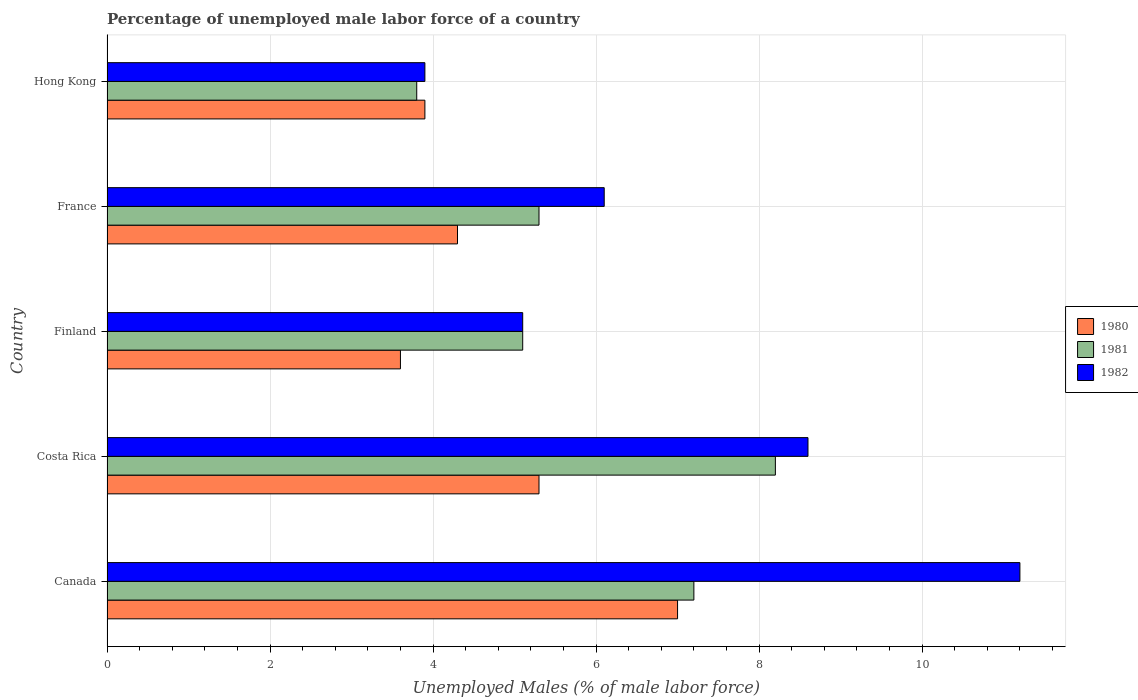How many groups of bars are there?
Your answer should be compact. 5. Are the number of bars per tick equal to the number of legend labels?
Your answer should be compact. Yes. In how many cases, is the number of bars for a given country not equal to the number of legend labels?
Your response must be concise. 0. What is the percentage of unemployed male labor force in 1981 in Finland?
Offer a very short reply. 5.1. Across all countries, what is the maximum percentage of unemployed male labor force in 1982?
Your answer should be very brief. 11.2. Across all countries, what is the minimum percentage of unemployed male labor force in 1981?
Your answer should be compact. 3.8. In which country was the percentage of unemployed male labor force in 1980 minimum?
Your answer should be very brief. Finland. What is the total percentage of unemployed male labor force in 1981 in the graph?
Offer a terse response. 29.6. What is the difference between the percentage of unemployed male labor force in 1982 in Canada and that in France?
Offer a terse response. 5.1. What is the difference between the percentage of unemployed male labor force in 1982 in Hong Kong and the percentage of unemployed male labor force in 1981 in France?
Ensure brevity in your answer.  -1.4. What is the average percentage of unemployed male labor force in 1982 per country?
Your answer should be compact. 6.98. What is the difference between the percentage of unemployed male labor force in 1981 and percentage of unemployed male labor force in 1980 in Costa Rica?
Give a very brief answer. 2.9. What is the ratio of the percentage of unemployed male labor force in 1981 in Finland to that in Hong Kong?
Offer a terse response. 1.34. Is the difference between the percentage of unemployed male labor force in 1981 in France and Hong Kong greater than the difference between the percentage of unemployed male labor force in 1980 in France and Hong Kong?
Your response must be concise. Yes. What is the difference between the highest and the second highest percentage of unemployed male labor force in 1980?
Your answer should be very brief. 1.7. What is the difference between the highest and the lowest percentage of unemployed male labor force in 1982?
Ensure brevity in your answer.  7.3. Is the sum of the percentage of unemployed male labor force in 1981 in Costa Rica and Finland greater than the maximum percentage of unemployed male labor force in 1980 across all countries?
Keep it short and to the point. Yes. What does the 3rd bar from the top in France represents?
Make the answer very short. 1980. Is it the case that in every country, the sum of the percentage of unemployed male labor force in 1981 and percentage of unemployed male labor force in 1980 is greater than the percentage of unemployed male labor force in 1982?
Ensure brevity in your answer.  Yes. What is the difference between two consecutive major ticks on the X-axis?
Your answer should be compact. 2. Does the graph contain any zero values?
Provide a succinct answer. No. Does the graph contain grids?
Your response must be concise. Yes. What is the title of the graph?
Offer a terse response. Percentage of unemployed male labor force of a country. Does "1993" appear as one of the legend labels in the graph?
Keep it short and to the point. No. What is the label or title of the X-axis?
Provide a short and direct response. Unemployed Males (% of male labor force). What is the label or title of the Y-axis?
Keep it short and to the point. Country. What is the Unemployed Males (% of male labor force) of 1981 in Canada?
Ensure brevity in your answer.  7.2. What is the Unemployed Males (% of male labor force) in 1982 in Canada?
Make the answer very short. 11.2. What is the Unemployed Males (% of male labor force) in 1980 in Costa Rica?
Offer a terse response. 5.3. What is the Unemployed Males (% of male labor force) in 1981 in Costa Rica?
Provide a short and direct response. 8.2. What is the Unemployed Males (% of male labor force) of 1982 in Costa Rica?
Provide a succinct answer. 8.6. What is the Unemployed Males (% of male labor force) of 1980 in Finland?
Ensure brevity in your answer.  3.6. What is the Unemployed Males (% of male labor force) of 1981 in Finland?
Ensure brevity in your answer.  5.1. What is the Unemployed Males (% of male labor force) of 1982 in Finland?
Ensure brevity in your answer.  5.1. What is the Unemployed Males (% of male labor force) in 1980 in France?
Make the answer very short. 4.3. What is the Unemployed Males (% of male labor force) of 1981 in France?
Give a very brief answer. 5.3. What is the Unemployed Males (% of male labor force) in 1982 in France?
Your answer should be compact. 6.1. What is the Unemployed Males (% of male labor force) of 1980 in Hong Kong?
Provide a succinct answer. 3.9. What is the Unemployed Males (% of male labor force) of 1981 in Hong Kong?
Provide a succinct answer. 3.8. What is the Unemployed Males (% of male labor force) in 1982 in Hong Kong?
Provide a succinct answer. 3.9. Across all countries, what is the maximum Unemployed Males (% of male labor force) in 1980?
Your answer should be compact. 7. Across all countries, what is the maximum Unemployed Males (% of male labor force) of 1981?
Offer a terse response. 8.2. Across all countries, what is the maximum Unemployed Males (% of male labor force) in 1982?
Ensure brevity in your answer.  11.2. Across all countries, what is the minimum Unemployed Males (% of male labor force) in 1980?
Your response must be concise. 3.6. Across all countries, what is the minimum Unemployed Males (% of male labor force) in 1981?
Offer a very short reply. 3.8. Across all countries, what is the minimum Unemployed Males (% of male labor force) in 1982?
Your answer should be very brief. 3.9. What is the total Unemployed Males (% of male labor force) of 1980 in the graph?
Offer a very short reply. 24.1. What is the total Unemployed Males (% of male labor force) of 1981 in the graph?
Provide a succinct answer. 29.6. What is the total Unemployed Males (% of male labor force) in 1982 in the graph?
Your response must be concise. 34.9. What is the difference between the Unemployed Males (% of male labor force) of 1980 in Canada and that in Costa Rica?
Offer a terse response. 1.7. What is the difference between the Unemployed Males (% of male labor force) of 1981 in Canada and that in Costa Rica?
Your response must be concise. -1. What is the difference between the Unemployed Males (% of male labor force) in 1982 in Canada and that in Costa Rica?
Keep it short and to the point. 2.6. What is the difference between the Unemployed Males (% of male labor force) of 1980 in Canada and that in Finland?
Ensure brevity in your answer.  3.4. What is the difference between the Unemployed Males (% of male labor force) of 1981 in Canada and that in Finland?
Ensure brevity in your answer.  2.1. What is the difference between the Unemployed Males (% of male labor force) in 1982 in Canada and that in France?
Provide a short and direct response. 5.1. What is the difference between the Unemployed Males (% of male labor force) of 1980 in Canada and that in Hong Kong?
Ensure brevity in your answer.  3.1. What is the difference between the Unemployed Males (% of male labor force) of 1980 in Costa Rica and that in Finland?
Provide a short and direct response. 1.7. What is the difference between the Unemployed Males (% of male labor force) in 1982 in Costa Rica and that in France?
Make the answer very short. 2.5. What is the difference between the Unemployed Males (% of male labor force) of 1980 in Costa Rica and that in Hong Kong?
Ensure brevity in your answer.  1.4. What is the difference between the Unemployed Males (% of male labor force) in 1982 in Costa Rica and that in Hong Kong?
Keep it short and to the point. 4.7. What is the difference between the Unemployed Males (% of male labor force) of 1980 in Finland and that in Hong Kong?
Your answer should be very brief. -0.3. What is the difference between the Unemployed Males (% of male labor force) of 1981 in France and that in Hong Kong?
Make the answer very short. 1.5. What is the difference between the Unemployed Males (% of male labor force) in 1980 in Canada and the Unemployed Males (% of male labor force) in 1982 in Costa Rica?
Offer a very short reply. -1.6. What is the difference between the Unemployed Males (% of male labor force) in 1981 in Canada and the Unemployed Males (% of male labor force) in 1982 in Costa Rica?
Keep it short and to the point. -1.4. What is the difference between the Unemployed Males (% of male labor force) in 1980 in Canada and the Unemployed Males (% of male labor force) in 1981 in Finland?
Keep it short and to the point. 1.9. What is the difference between the Unemployed Males (% of male labor force) of 1981 in Canada and the Unemployed Males (% of male labor force) of 1982 in Finland?
Ensure brevity in your answer.  2.1. What is the difference between the Unemployed Males (% of male labor force) of 1980 in Canada and the Unemployed Males (% of male labor force) of 1982 in France?
Your answer should be very brief. 0.9. What is the difference between the Unemployed Males (% of male labor force) in 1981 in Canada and the Unemployed Males (% of male labor force) in 1982 in France?
Give a very brief answer. 1.1. What is the difference between the Unemployed Males (% of male labor force) in 1980 in Canada and the Unemployed Males (% of male labor force) in 1981 in Hong Kong?
Provide a succinct answer. 3.2. What is the difference between the Unemployed Males (% of male labor force) of 1980 in Canada and the Unemployed Males (% of male labor force) of 1982 in Hong Kong?
Ensure brevity in your answer.  3.1. What is the difference between the Unemployed Males (% of male labor force) of 1980 in Costa Rica and the Unemployed Males (% of male labor force) of 1982 in France?
Give a very brief answer. -0.8. What is the difference between the Unemployed Males (% of male labor force) of 1981 in Costa Rica and the Unemployed Males (% of male labor force) of 1982 in France?
Provide a succinct answer. 2.1. What is the difference between the Unemployed Males (% of male labor force) of 1981 in Costa Rica and the Unemployed Males (% of male labor force) of 1982 in Hong Kong?
Give a very brief answer. 4.3. What is the difference between the Unemployed Males (% of male labor force) of 1980 in Finland and the Unemployed Males (% of male labor force) of 1982 in France?
Provide a short and direct response. -2.5. What is the difference between the Unemployed Males (% of male labor force) in 1980 in Finland and the Unemployed Males (% of male labor force) in 1981 in Hong Kong?
Ensure brevity in your answer.  -0.2. What is the difference between the Unemployed Males (% of male labor force) of 1980 in France and the Unemployed Males (% of male labor force) of 1982 in Hong Kong?
Provide a short and direct response. 0.4. What is the average Unemployed Males (% of male labor force) in 1980 per country?
Ensure brevity in your answer.  4.82. What is the average Unemployed Males (% of male labor force) of 1981 per country?
Ensure brevity in your answer.  5.92. What is the average Unemployed Males (% of male labor force) in 1982 per country?
Your answer should be very brief. 6.98. What is the difference between the Unemployed Males (% of male labor force) in 1980 and Unemployed Males (% of male labor force) in 1981 in Canada?
Ensure brevity in your answer.  -0.2. What is the difference between the Unemployed Males (% of male labor force) of 1981 and Unemployed Males (% of male labor force) of 1982 in Canada?
Keep it short and to the point. -4. What is the difference between the Unemployed Males (% of male labor force) in 1980 and Unemployed Males (% of male labor force) in 1981 in Finland?
Make the answer very short. -1.5. What is the difference between the Unemployed Males (% of male labor force) of 1980 and Unemployed Males (% of male labor force) of 1982 in Finland?
Provide a short and direct response. -1.5. What is the difference between the Unemployed Males (% of male labor force) of 1981 and Unemployed Males (% of male labor force) of 1982 in Finland?
Offer a very short reply. 0. What is the difference between the Unemployed Males (% of male labor force) in 1981 and Unemployed Males (% of male labor force) in 1982 in France?
Provide a succinct answer. -0.8. What is the ratio of the Unemployed Males (% of male labor force) in 1980 in Canada to that in Costa Rica?
Your response must be concise. 1.32. What is the ratio of the Unemployed Males (% of male labor force) of 1981 in Canada to that in Costa Rica?
Your response must be concise. 0.88. What is the ratio of the Unemployed Males (% of male labor force) of 1982 in Canada to that in Costa Rica?
Offer a very short reply. 1.3. What is the ratio of the Unemployed Males (% of male labor force) of 1980 in Canada to that in Finland?
Your answer should be very brief. 1.94. What is the ratio of the Unemployed Males (% of male labor force) in 1981 in Canada to that in Finland?
Ensure brevity in your answer.  1.41. What is the ratio of the Unemployed Males (% of male labor force) of 1982 in Canada to that in Finland?
Provide a short and direct response. 2.2. What is the ratio of the Unemployed Males (% of male labor force) of 1980 in Canada to that in France?
Your answer should be compact. 1.63. What is the ratio of the Unemployed Males (% of male labor force) in 1981 in Canada to that in France?
Offer a terse response. 1.36. What is the ratio of the Unemployed Males (% of male labor force) of 1982 in Canada to that in France?
Keep it short and to the point. 1.84. What is the ratio of the Unemployed Males (% of male labor force) of 1980 in Canada to that in Hong Kong?
Ensure brevity in your answer.  1.79. What is the ratio of the Unemployed Males (% of male labor force) in 1981 in Canada to that in Hong Kong?
Give a very brief answer. 1.89. What is the ratio of the Unemployed Males (% of male labor force) of 1982 in Canada to that in Hong Kong?
Ensure brevity in your answer.  2.87. What is the ratio of the Unemployed Males (% of male labor force) in 1980 in Costa Rica to that in Finland?
Offer a very short reply. 1.47. What is the ratio of the Unemployed Males (% of male labor force) of 1981 in Costa Rica to that in Finland?
Keep it short and to the point. 1.61. What is the ratio of the Unemployed Males (% of male labor force) in 1982 in Costa Rica to that in Finland?
Offer a very short reply. 1.69. What is the ratio of the Unemployed Males (% of male labor force) in 1980 in Costa Rica to that in France?
Offer a very short reply. 1.23. What is the ratio of the Unemployed Males (% of male labor force) in 1981 in Costa Rica to that in France?
Offer a very short reply. 1.55. What is the ratio of the Unemployed Males (% of male labor force) in 1982 in Costa Rica to that in France?
Make the answer very short. 1.41. What is the ratio of the Unemployed Males (% of male labor force) of 1980 in Costa Rica to that in Hong Kong?
Offer a very short reply. 1.36. What is the ratio of the Unemployed Males (% of male labor force) in 1981 in Costa Rica to that in Hong Kong?
Provide a succinct answer. 2.16. What is the ratio of the Unemployed Males (% of male labor force) in 1982 in Costa Rica to that in Hong Kong?
Your answer should be very brief. 2.21. What is the ratio of the Unemployed Males (% of male labor force) of 1980 in Finland to that in France?
Your response must be concise. 0.84. What is the ratio of the Unemployed Males (% of male labor force) of 1981 in Finland to that in France?
Your answer should be compact. 0.96. What is the ratio of the Unemployed Males (% of male labor force) of 1982 in Finland to that in France?
Offer a terse response. 0.84. What is the ratio of the Unemployed Males (% of male labor force) of 1981 in Finland to that in Hong Kong?
Ensure brevity in your answer.  1.34. What is the ratio of the Unemployed Males (% of male labor force) in 1982 in Finland to that in Hong Kong?
Offer a very short reply. 1.31. What is the ratio of the Unemployed Males (% of male labor force) in 1980 in France to that in Hong Kong?
Keep it short and to the point. 1.1. What is the ratio of the Unemployed Males (% of male labor force) of 1981 in France to that in Hong Kong?
Your answer should be compact. 1.39. What is the ratio of the Unemployed Males (% of male labor force) of 1982 in France to that in Hong Kong?
Your response must be concise. 1.56. What is the difference between the highest and the second highest Unemployed Males (% of male labor force) of 1981?
Give a very brief answer. 1. What is the difference between the highest and the lowest Unemployed Males (% of male labor force) in 1980?
Offer a terse response. 3.4. What is the difference between the highest and the lowest Unemployed Males (% of male labor force) in 1982?
Your answer should be very brief. 7.3. 